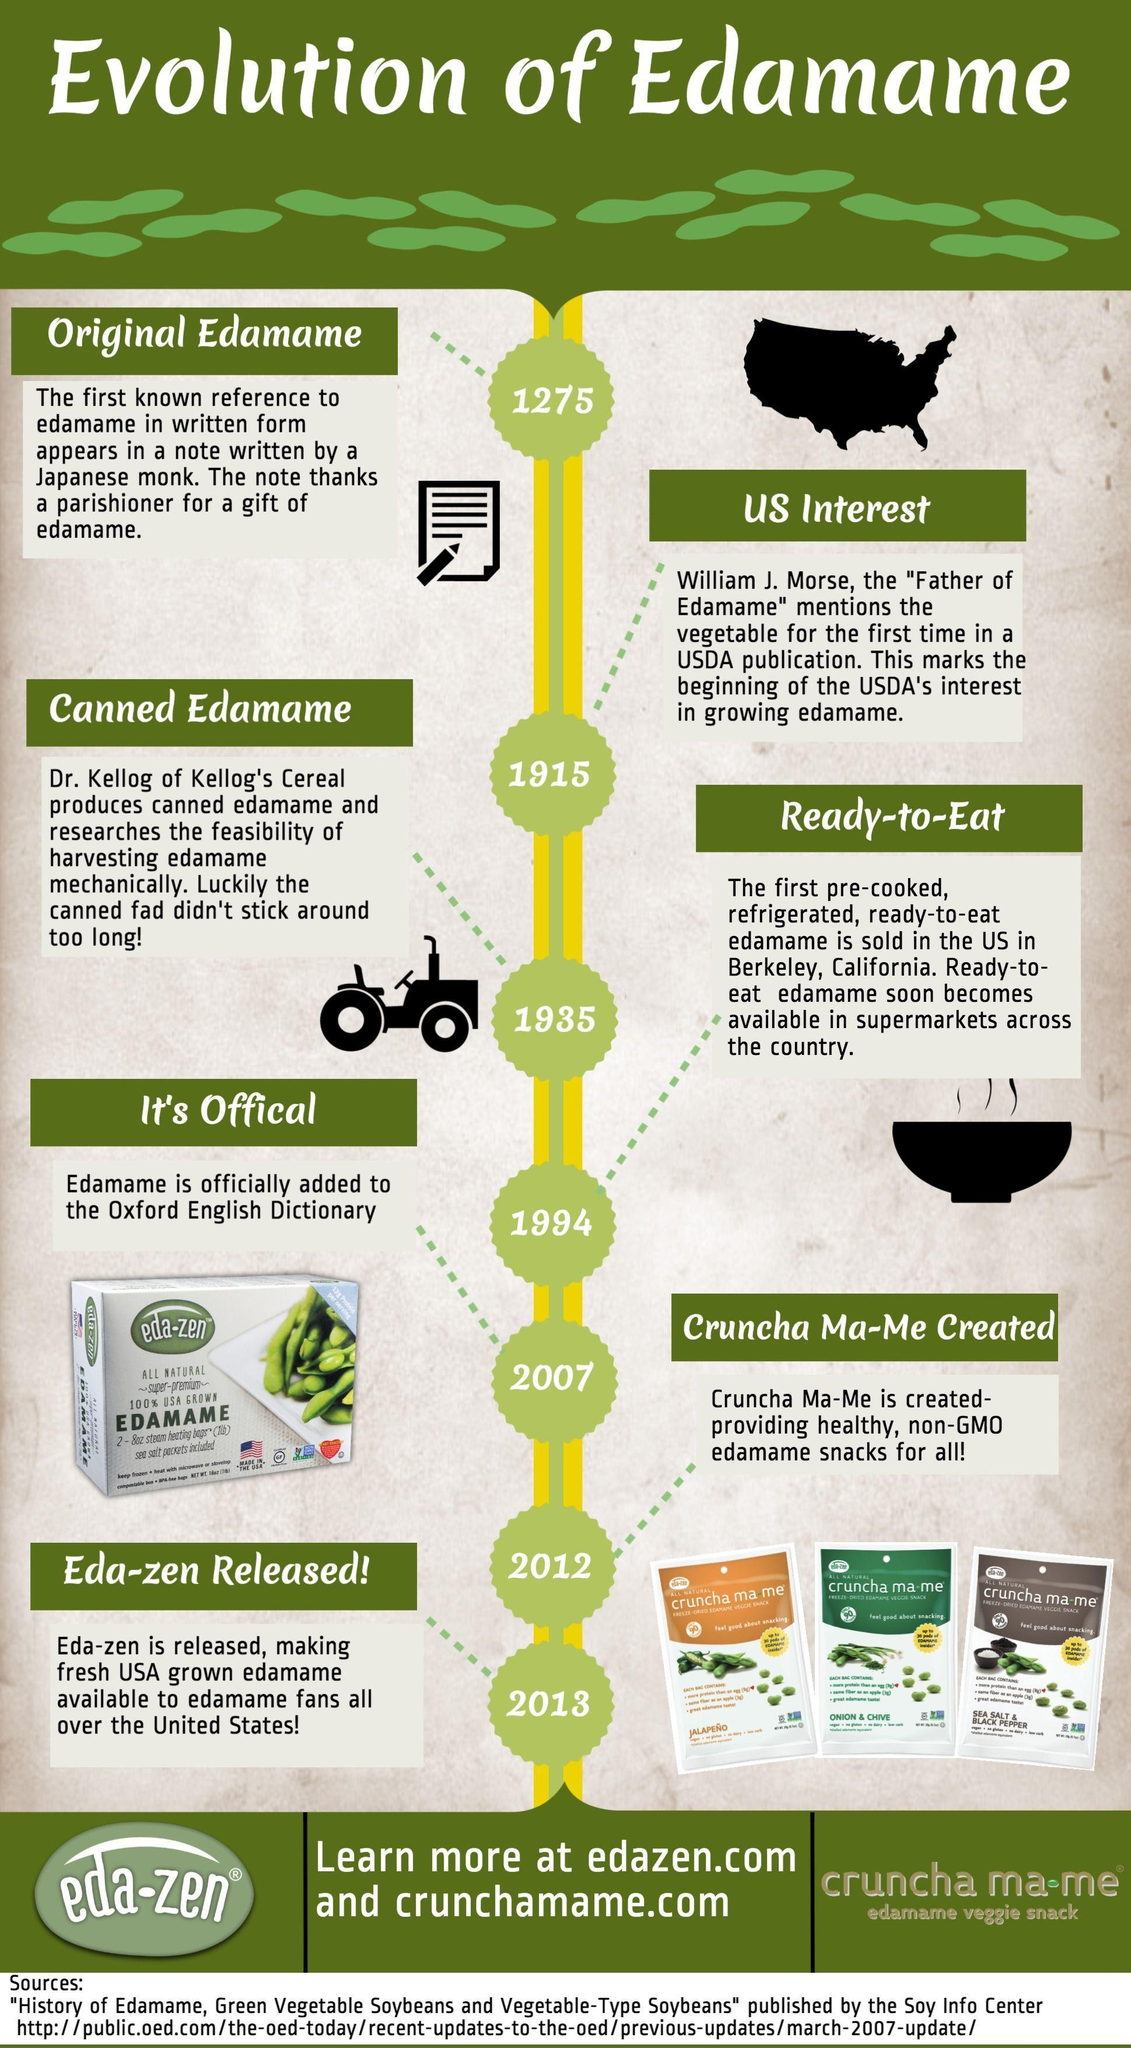How many flavors of Cruncha Ma-Me is available ?
Answer the question with a short phrase. 3 When was the first ready to eat Edamame introduced 1915, 1994, or 1935 ? 1994 When was the name 'Edamame' added to the dictionary 2012, 2007, or 1994 ? 2007 Which is the flavor of the green pack of Cruncha Ma-Me? Onion & Chive When was the name Edamame first mentioned in 1935, 1275, 2013 or 1994? 1275 What is the flavor of Cruncha Ma-Me brown Pack? Sea Salt & Black Pepper When was Eda-Zen released 2007, 2013 or 2012 ? 2013 What is the flavor of the Orange pack of Cruncha Ma-Me? JALAPENO 